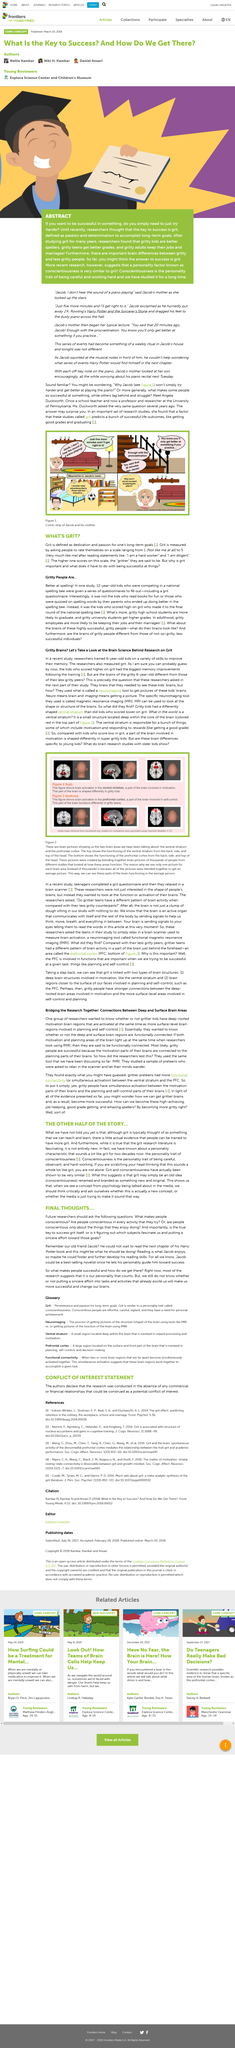Specify some key components in this picture. The comic strip in Figure 1 features a woman and a boy, with the woman being the boy's mother and the boy being the woman's son. Grittier preteens have more functional connectivity between the ventral striatum and the prefrontal cortex than their less gritty peers, according to the study. Gritty people are successful because their motivation and planning brain functions are connected, which enables them to persevere in pursuing their goals. Angela Duckworth, who was once a school teacher, is now known for her research on grit and self-control. The ventral striatum, located deep within the core of the brain, is responsible for motivation and responding to rewards. 